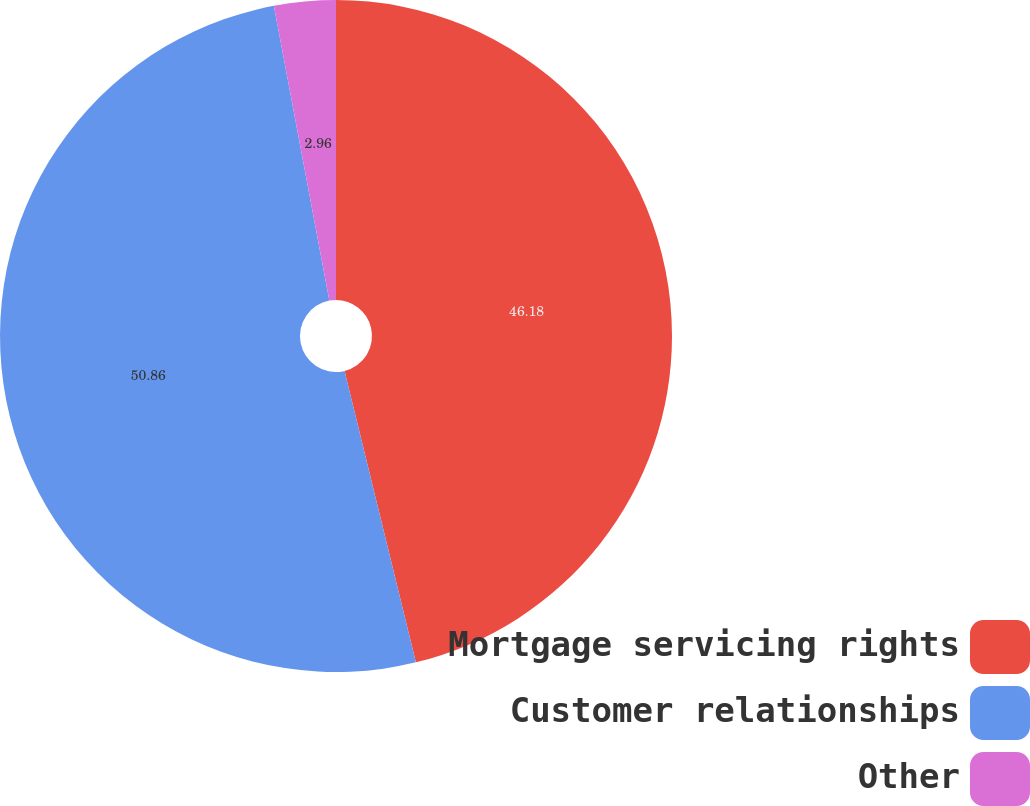Convert chart. <chart><loc_0><loc_0><loc_500><loc_500><pie_chart><fcel>Mortgage servicing rights<fcel>Customer relationships<fcel>Other<nl><fcel>46.18%<fcel>50.86%<fcel>2.96%<nl></chart> 